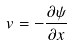Convert formula to latex. <formula><loc_0><loc_0><loc_500><loc_500>v = - \frac { \partial \psi } { \partial x }</formula> 